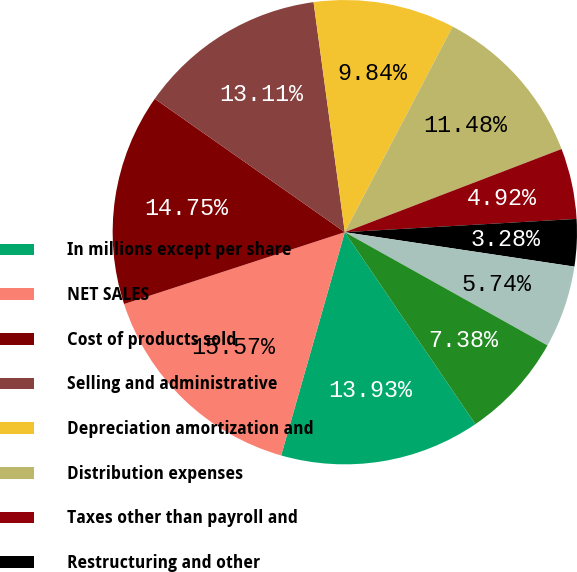<chart> <loc_0><loc_0><loc_500><loc_500><pie_chart><fcel>In millions except per share<fcel>NET SALES<fcel>Cost of products sold<fcel>Selling and administrative<fcel>Depreciation amortization and<fcel>Distribution expenses<fcel>Taxes other than payroll and<fcel>Restructuring and other<fcel>Net (gains) losses on sales<fcel>Interest expense net<nl><fcel>13.93%<fcel>15.57%<fcel>14.75%<fcel>13.11%<fcel>9.84%<fcel>11.48%<fcel>4.92%<fcel>3.28%<fcel>5.74%<fcel>7.38%<nl></chart> 